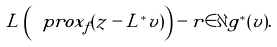Convert formula to latex. <formula><loc_0><loc_0><loc_500><loc_500>L \left ( \ p r o x _ { f } ( z - L ^ { * } v ) \right ) - r \in \partial g ^ { * } ( v ) .</formula> 